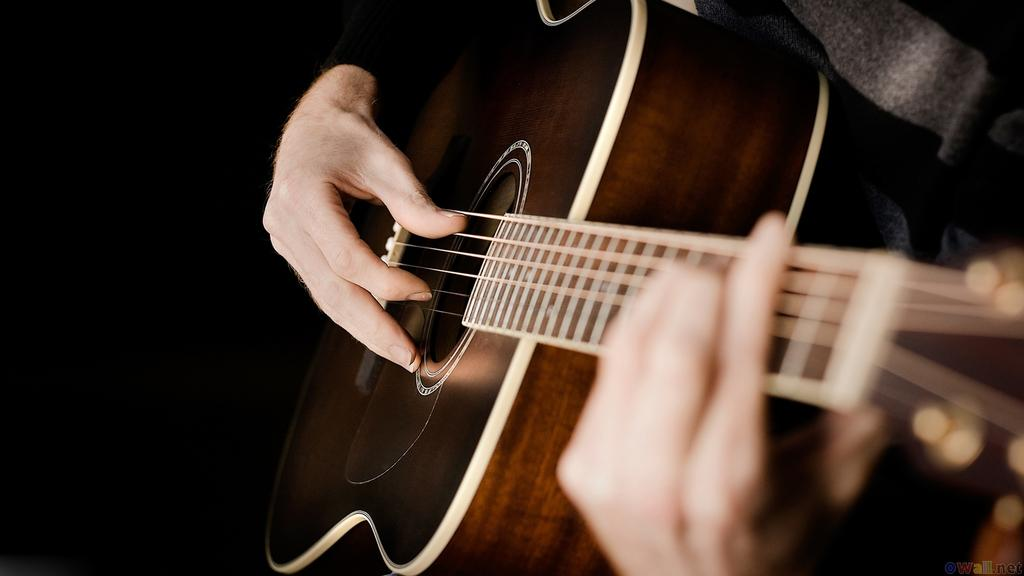Who is the main subject in the image? There is a person in the image. What is the person holding in the image? The person is holding a wooden guitar. What color is the background of the guitar? The background of the guitar is in black color. What day of the week is the person playing the guitar on? The day of the week is not mentioned or visible in the image, so it cannot be determined. 